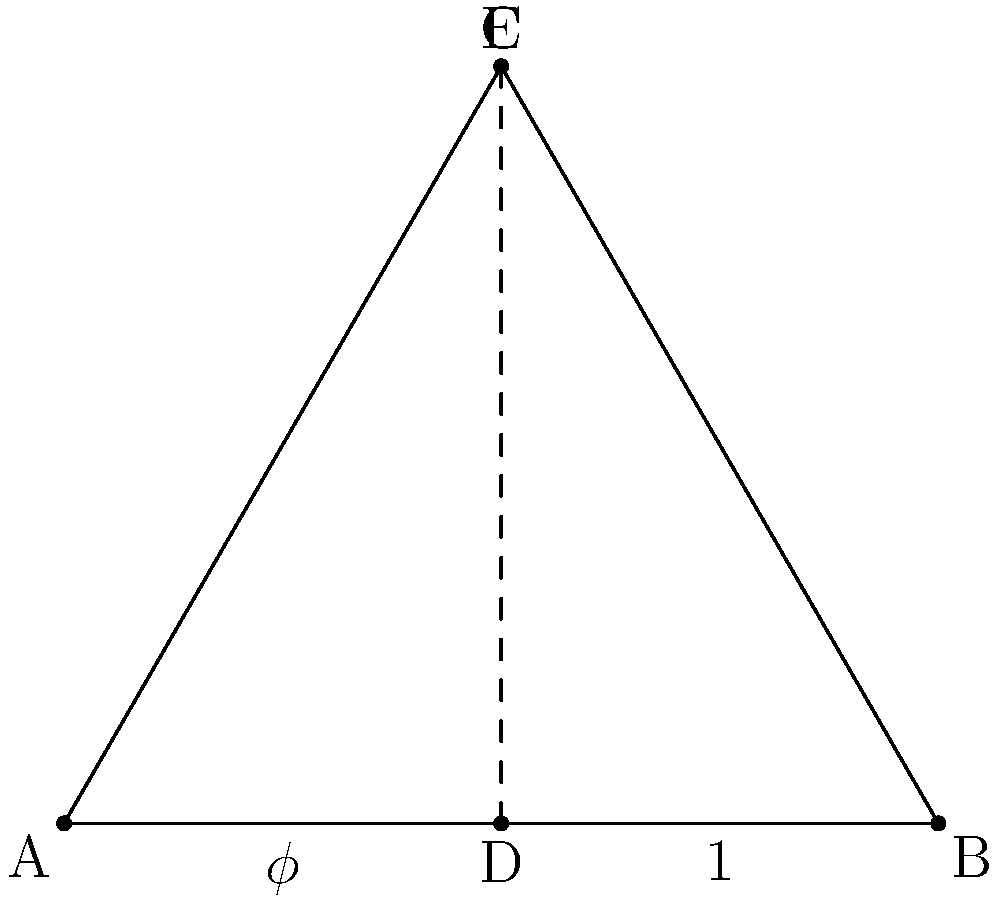In the ancient pyramid structure depicted above, the ratio of the longer segment (AD) to the shorter segment (DB) is believed to be the golden ratio ($\phi$). If DB = 1 unit, what is the exact value of AD? Some claim this ratio was intentionally used by secret societies to encode hidden knowledge. How might this support or refute that theory? Let's approach this step-by-step:

1) The golden ratio $\phi$ is defined as the ratio of the sum of two quantities to the larger quantity, which is equal to the ratio of the larger quantity to the smaller quantity.

2) Mathematically, this is expressed as: $\frac{a+b}{a} = \frac{a}{b} = \phi$

3) We're given that DB = 1 unit. Let's call AD = x units.

4) According to the golden ratio definition: $\frac{x+1}{x} = \frac{x}{1} = \phi$

5) This can be written as a quadratic equation: $x^2 = x + 1$

6) Solving this equation:
   $x^2 - x - 1 = 0$
   $(x - \frac{1+\sqrt{5}}{2})(x - \frac{1-\sqrt{5}}{2}) = 0$

7) The positive solution to this equation is: $x = \frac{1+\sqrt{5}}{2}$

This value is exactly the golden ratio $\phi$. The presence of this ratio in ancient structures has led some to believe that secret societies intentionally used it to encode knowledge. However, it's important to note that the golden ratio occurs naturally in many systems, and its presence alone doesn't necessarily imply intentional encoding by secret societies. The theory remains controversial and open to interpretation.
Answer: $\frac{1+\sqrt{5}}{2}$ 